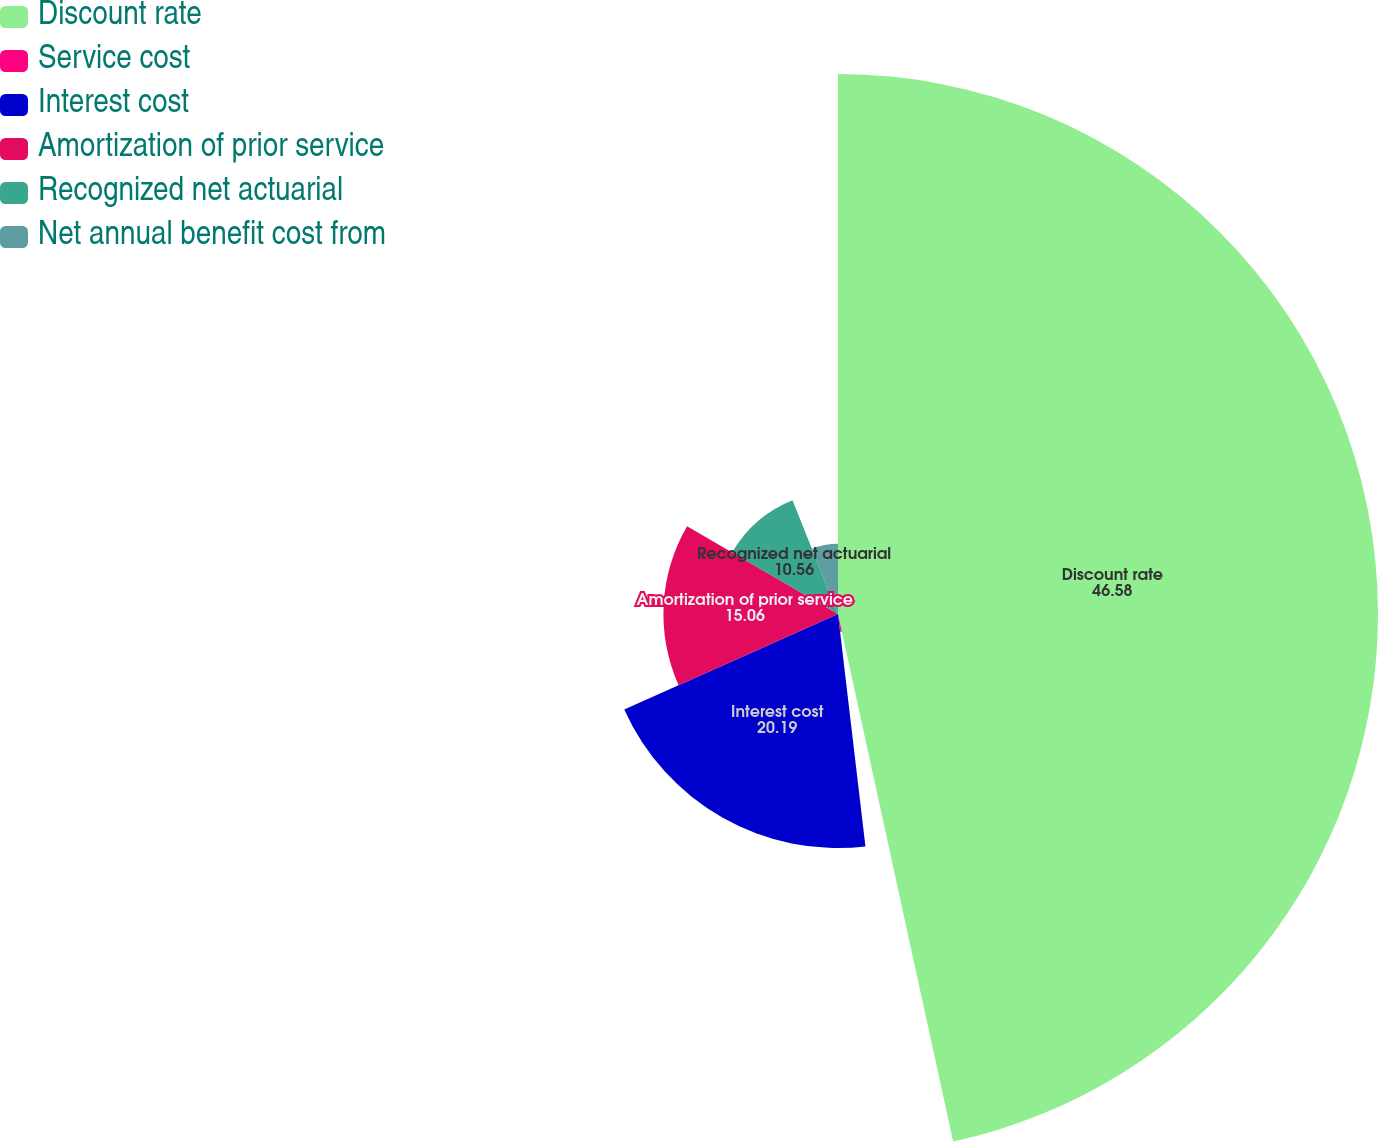Convert chart. <chart><loc_0><loc_0><loc_500><loc_500><pie_chart><fcel>Discount rate<fcel>Service cost<fcel>Interest cost<fcel>Amortization of prior service<fcel>Recognized net actuarial<fcel>Net annual benefit cost from<nl><fcel>46.58%<fcel>1.55%<fcel>20.19%<fcel>15.06%<fcel>10.56%<fcel>6.06%<nl></chart> 